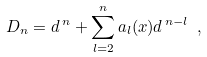<formula> <loc_0><loc_0><loc_500><loc_500>D _ { n } = { d } ^ { \, n } + \sum _ { l = 2 } ^ { n } a _ { l } ( x ) { d } ^ { \, n - l } \ ,</formula> 